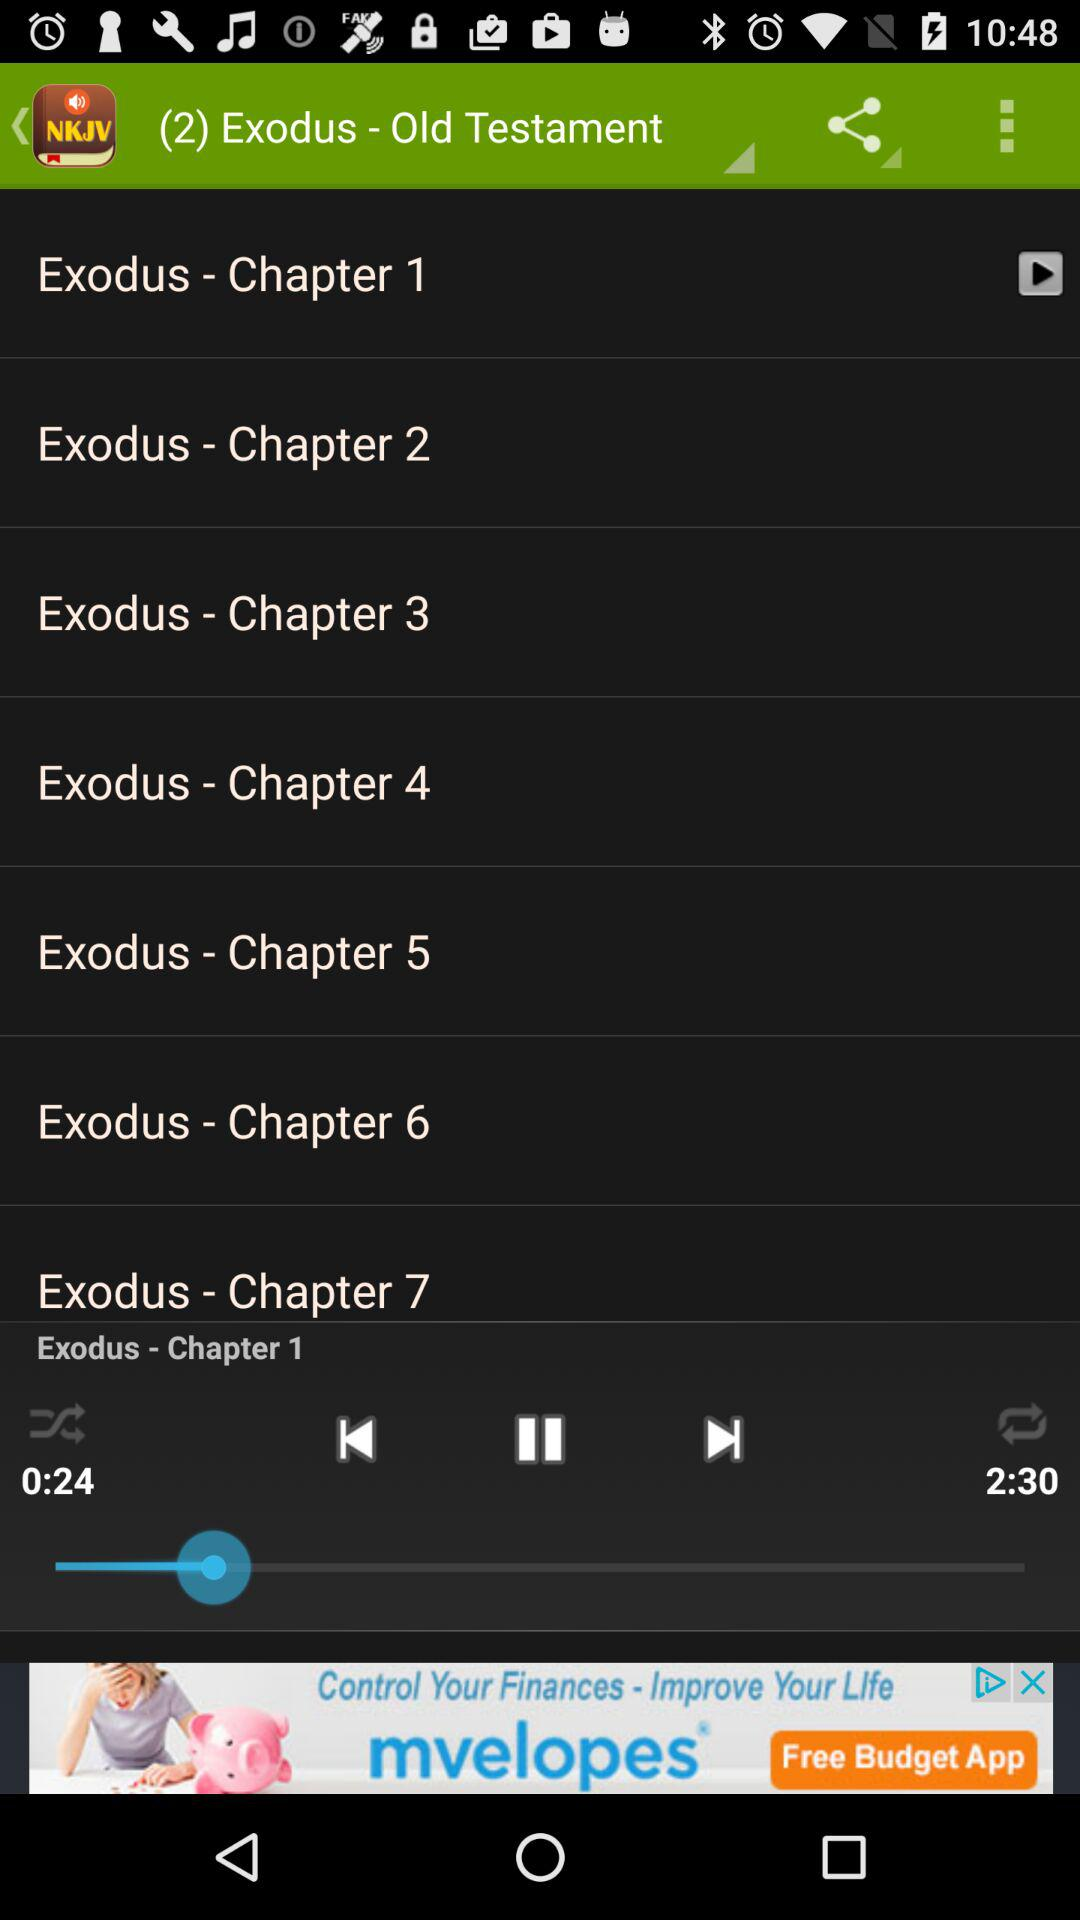How many chapters are in Exodus?
Answer the question using a single word or phrase. 7 